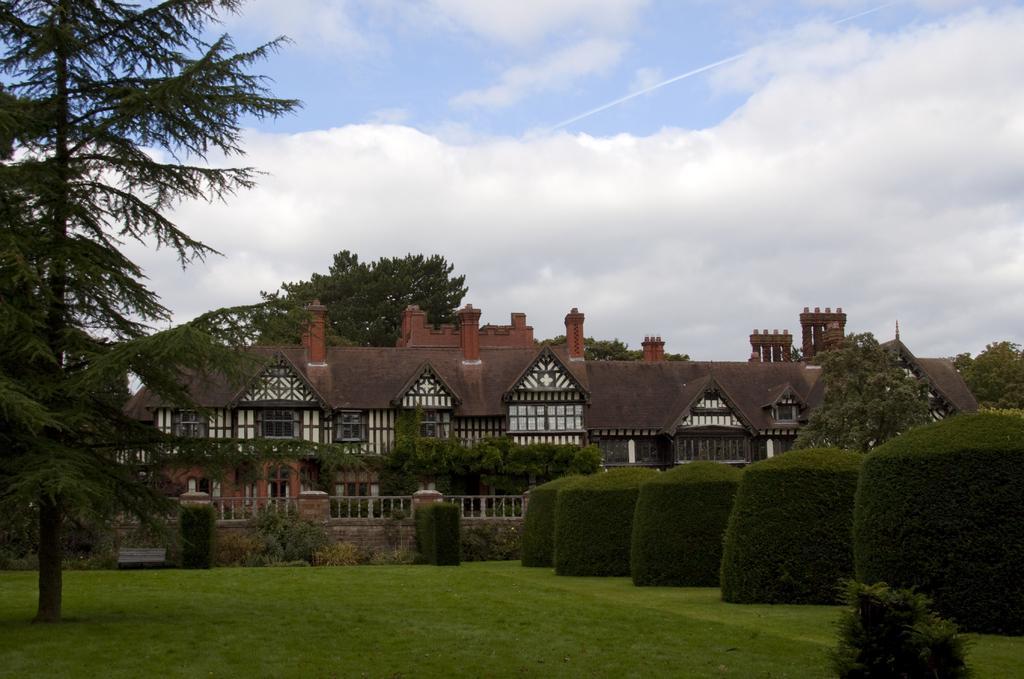How would you summarize this image in a sentence or two? In the picture I can see buildings, trees, plants, grass, fence and some other objects. In the background I can see the sky. 